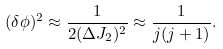<formula> <loc_0><loc_0><loc_500><loc_500>( \delta \phi ) ^ { 2 } \approx \frac { 1 } { 2 ( \Delta J _ { 2 } ) ^ { 2 } } \approx \frac { 1 } { j ( j + 1 ) } .</formula> 